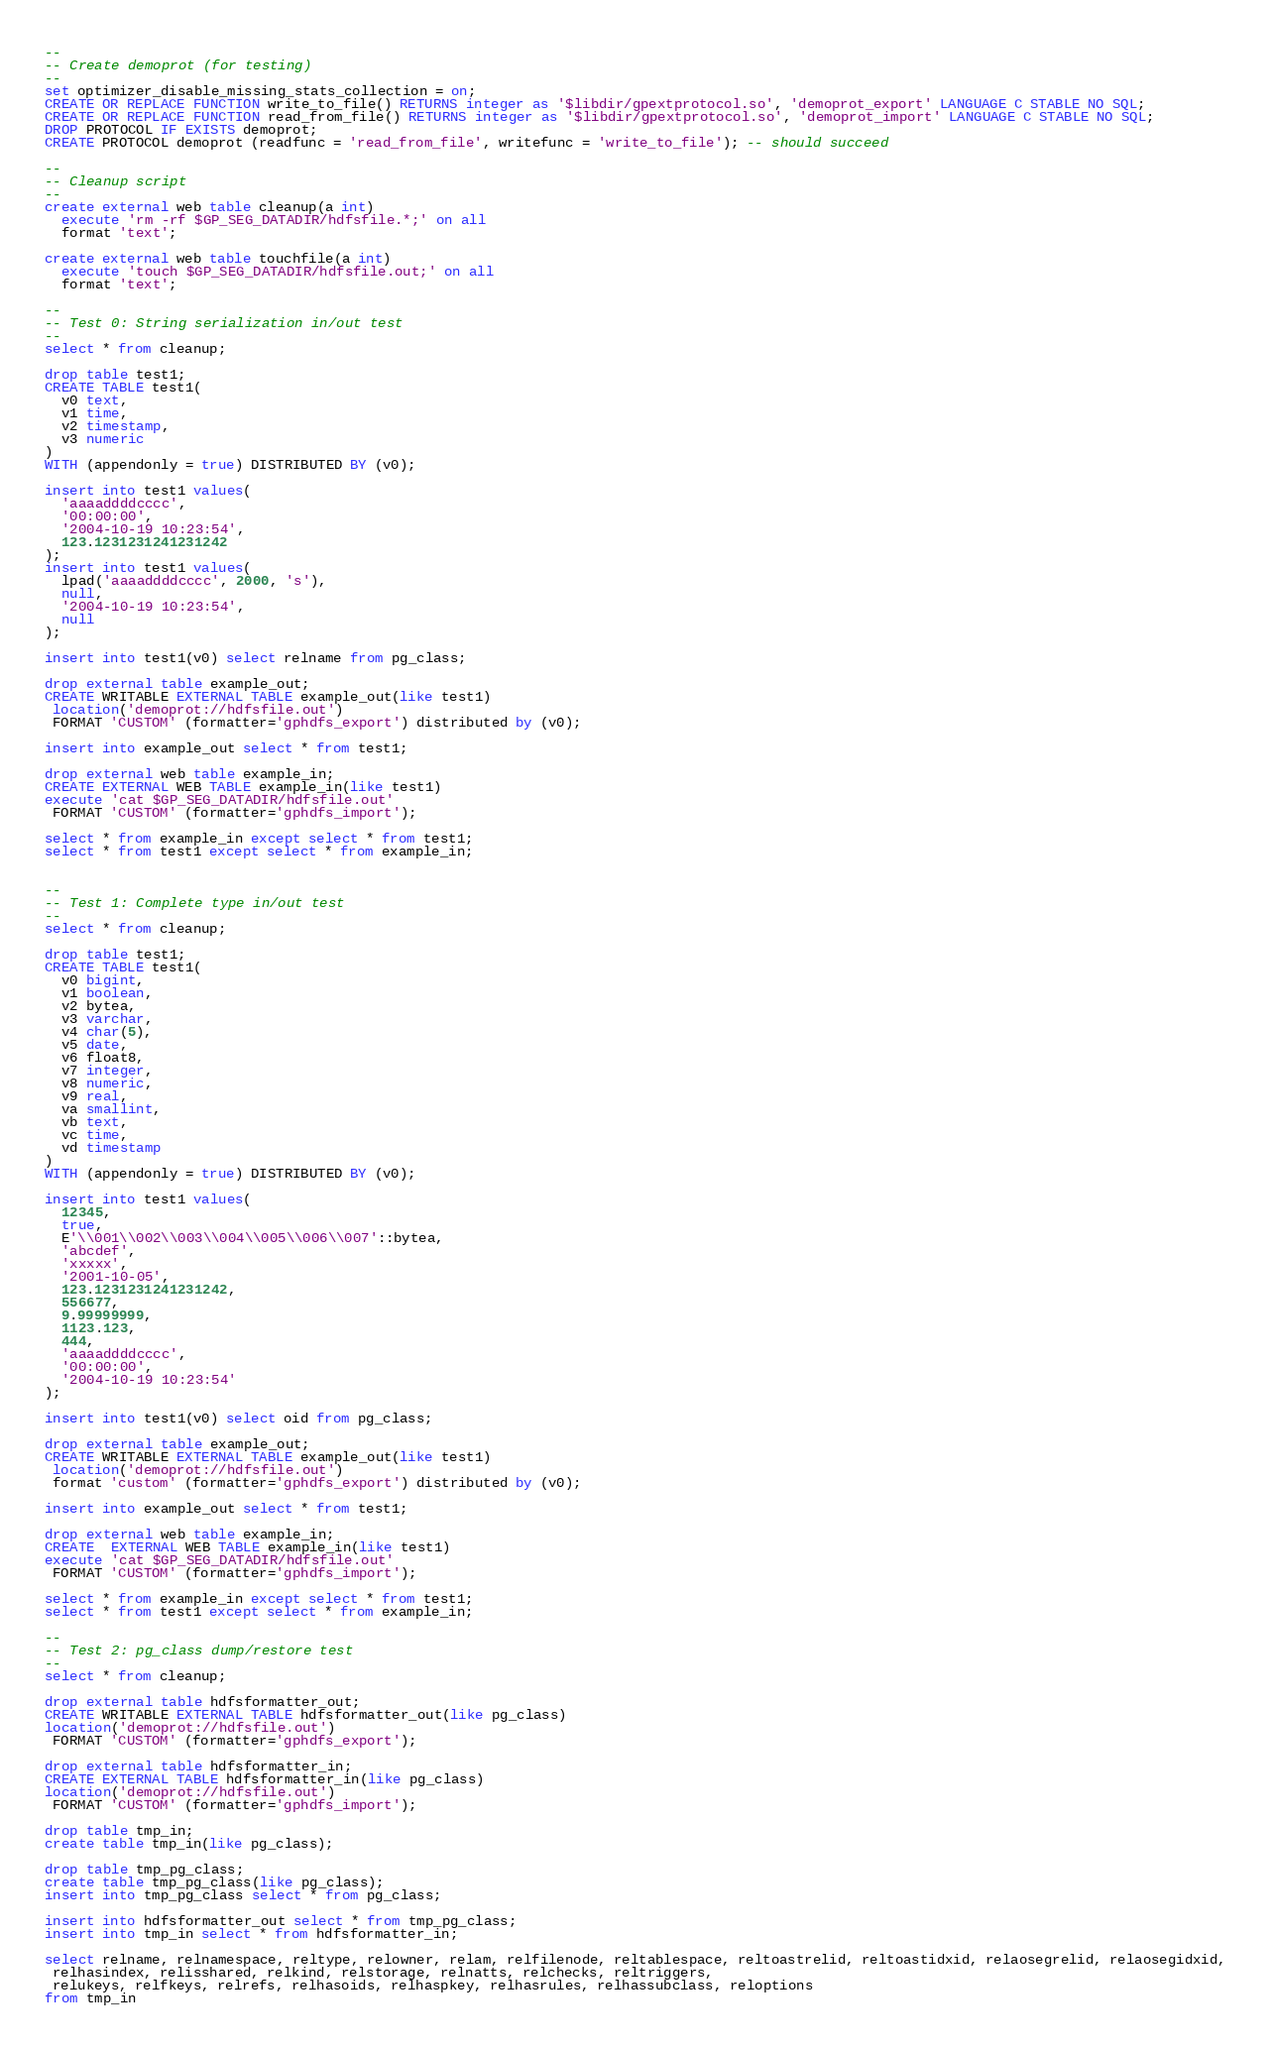<code> <loc_0><loc_0><loc_500><loc_500><_SQL_>--
-- Create demoprot (for testing)
--
set optimizer_disable_missing_stats_collection = on;
CREATE OR REPLACE FUNCTION write_to_file() RETURNS integer as '$libdir/gpextprotocol.so', 'demoprot_export' LANGUAGE C STABLE NO SQL;
CREATE OR REPLACE FUNCTION read_from_file() RETURNS integer as '$libdir/gpextprotocol.so', 'demoprot_import' LANGUAGE C STABLE NO SQL;
DROP PROTOCOL IF EXISTS demoprot;
CREATE PROTOCOL demoprot (readfunc = 'read_from_file', writefunc = 'write_to_file'); -- should succeed

--
-- Cleanup script
--
create external web table cleanup(a int)
  execute 'rm -rf $GP_SEG_DATADIR/hdfsfile.*;' on all
  format 'text';

create external web table touchfile(a int)
  execute 'touch $GP_SEG_DATADIR/hdfsfile.out;' on all
  format 'text';

--
-- Test 0: String serialization in/out test
--
select * from cleanup;

drop table test1;
CREATE TABLE test1(
  v0 text,
  v1 time,
  v2 timestamp,
  v3 numeric
) 
WITH (appendonly = true) DISTRIBUTED BY (v0);

insert into test1 values(
  'aaaaddddcccc',
  '00:00:00',
  '2004-10-19 10:23:54',
  123.1231231241231242
);
insert into test1 values(
  lpad('aaaaddddcccc', 2000, 's'),
  null,
  '2004-10-19 10:23:54',
  null
);

insert into test1(v0) select relname from pg_class;

drop external table example_out;
CREATE WRITABLE EXTERNAL TABLE example_out(like test1)
 location('demoprot://hdfsfile.out')
 FORMAT 'CUSTOM' (formatter='gphdfs_export') distributed by (v0);

insert into example_out select * from test1;

drop external web table example_in;
CREATE EXTERNAL WEB TABLE example_in(like test1)
execute 'cat $GP_SEG_DATADIR/hdfsfile.out'
 FORMAT 'CUSTOM' (formatter='gphdfs_import');

select * from example_in except select * from test1;
select * from test1 except select * from example_in;


--
-- Test 1: Complete type in/out test
--
select * from cleanup;

drop table test1;
CREATE TABLE test1(
  v0 bigint,
  v1 boolean,
  v2 bytea,
  v3 varchar,
  v4 char(5),
  v5 date,
  v6 float8,
  v7 integer,
  v8 numeric,
  v9 real,
  va smallint,
  vb text,
  vc time,
  vd timestamp
) 
WITH (appendonly = true) DISTRIBUTED BY (v0);

insert into test1 values(
  12345,
  true,
  E'\\001\\002\\003\\004\\005\\006\\007'::bytea,
  'abcdef',
  'xxxxx',
  '2001-10-05',
  123.1231231241231242,
  556677,
  9.99999999,
  1123.123,
  444,
  'aaaaddddcccc',
  '00:00:00',
  '2004-10-19 10:23:54'
);

insert into test1(v0) select oid from pg_class;

drop external table example_out;
CREATE WRITABLE EXTERNAL TABLE example_out(like test1)
 location('demoprot://hdfsfile.out')
 format 'custom' (formatter='gphdfs_export') distributed by (v0);

insert into example_out select * from test1;

drop external web table example_in;
CREATE  EXTERNAL WEB TABLE example_in(like test1)
execute 'cat $GP_SEG_DATADIR/hdfsfile.out'
 FORMAT 'CUSTOM' (formatter='gphdfs_import');

select * from example_in except select * from test1;
select * from test1 except select * from example_in;

--
-- Test 2: pg_class dump/restore test
--
select * from cleanup;

drop external table hdfsformatter_out;
CREATE WRITABLE EXTERNAL TABLE hdfsformatter_out(like pg_class)
location('demoprot://hdfsfile.out')
 FORMAT 'CUSTOM' (formatter='gphdfs_export');

drop external table hdfsformatter_in;
CREATE EXTERNAL TABLE hdfsformatter_in(like pg_class)
location('demoprot://hdfsfile.out')
 FORMAT 'CUSTOM' (formatter='gphdfs_import');

drop table tmp_in;
create table tmp_in(like pg_class);

drop table tmp_pg_class;
create table tmp_pg_class(like pg_class);
insert into tmp_pg_class select * from pg_class;

insert into hdfsformatter_out select * from tmp_pg_class;
insert into tmp_in select * from hdfsformatter_in;

select relname, relnamespace, reltype, relowner, relam, relfilenode, reltablespace, reltoastrelid, reltoastidxid, relaosegrelid, relaosegidxid,
 relhasindex, relisshared, relkind, relstorage, relnatts, relchecks, reltriggers,
 relukeys, relfkeys, relrefs, relhasoids, relhaspkey, relhasrules, relhassubclass, reloptions
from tmp_in</code> 